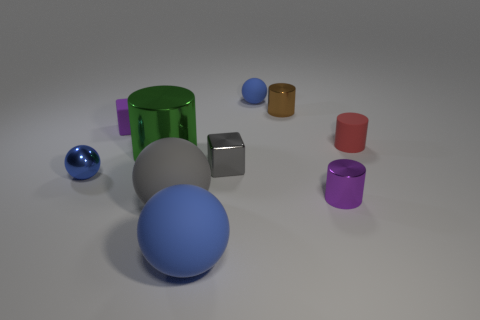What shape is the purple object right of the blue object that is in front of the tiny blue object that is left of the matte cube?
Your response must be concise. Cylinder. There is a blue sphere that is left of the purple matte block; does it have the same size as the gray object behind the small shiny ball?
Make the answer very short. Yes. What number of small red things have the same material as the big blue thing?
Make the answer very short. 1. There is a tiny blue thing in front of the small blue sphere behind the small purple rubber thing; how many tiny purple metallic things are in front of it?
Make the answer very short. 1. Is the shape of the tiny brown object the same as the small red rubber object?
Your response must be concise. Yes. Are there any other shiny objects of the same shape as the green object?
Ensure brevity in your answer.  Yes. There is a brown object that is the same size as the red thing; what shape is it?
Ensure brevity in your answer.  Cylinder. There is a blue thing that is behind the purple thing that is on the left side of the blue matte sphere that is in front of the big shiny cylinder; what is its material?
Provide a succinct answer. Rubber. Do the purple block and the green object have the same size?
Your answer should be very brief. No. What material is the tiny brown object?
Keep it short and to the point. Metal. 